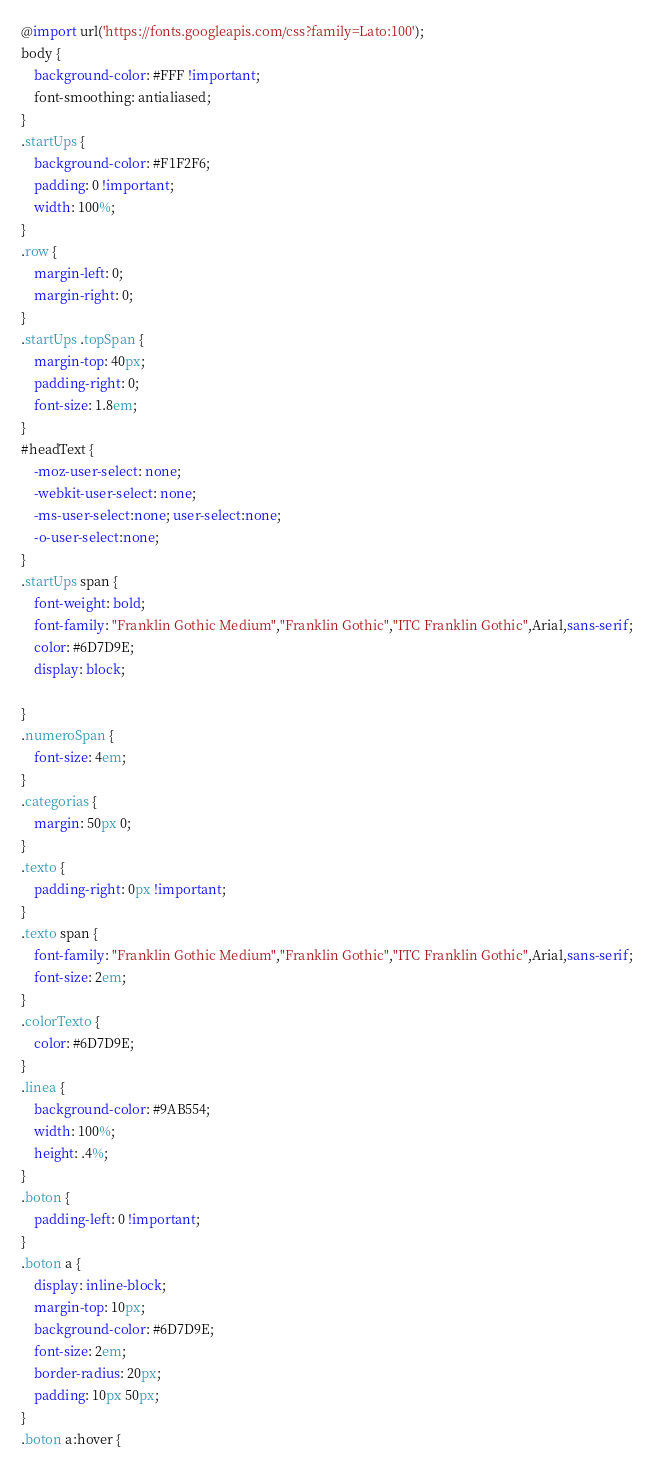Convert code to text. <code><loc_0><loc_0><loc_500><loc_500><_CSS_>@import url('https://fonts.googleapis.com/css?family=Lato:100');
body {
	background-color: #FFF !important;
	font-smoothing: antialiased;
}
.startUps {
	background-color: #F1F2F6;
	padding: 0 !important;
	width: 100%;
}
.row {
	margin-left: 0;
	margin-right: 0;
}
.startUps .topSpan {
	margin-top: 40px;
	padding-right: 0;
	font-size: 1.8em;
}
#headText {
	-moz-user-select: none; 
	-webkit-user-select: none; 
	-ms-user-select:none; user-select:none;
	-o-user-select:none;
}
.startUps span {
	font-weight: bold;
	font-family: "Franklin Gothic Medium","Franklin Gothic","ITC Franklin Gothic",Arial,sans-serif;
	color: #6D7D9E;
	display: block;
	
}
.numeroSpan {
	font-size: 4em;
}
.categorias {
	margin: 50px 0;
}
.texto {
	padding-right: 0px !important; 
}
.texto span {
	font-family: "Franklin Gothic Medium","Franklin Gothic","ITC Franklin Gothic",Arial,sans-serif;
	font-size: 2em;
}
.colorTexto {
	color: #6D7D9E;
}
.linea {
	background-color: #9AB554;
	width: 100%;
	height: .4%;
}
.boton {
	padding-left: 0 !important;
}
.boton a {
	display: inline-block;
	margin-top: 10px;
	background-color: #6D7D9E;
	font-size: 2em;
	border-radius: 20px;
	padding: 10px 50px;
}
.boton a:hover {</code> 